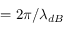Convert formula to latex. <formula><loc_0><loc_0><loc_500><loc_500>= 2 \pi / \lambda _ { d B }</formula> 